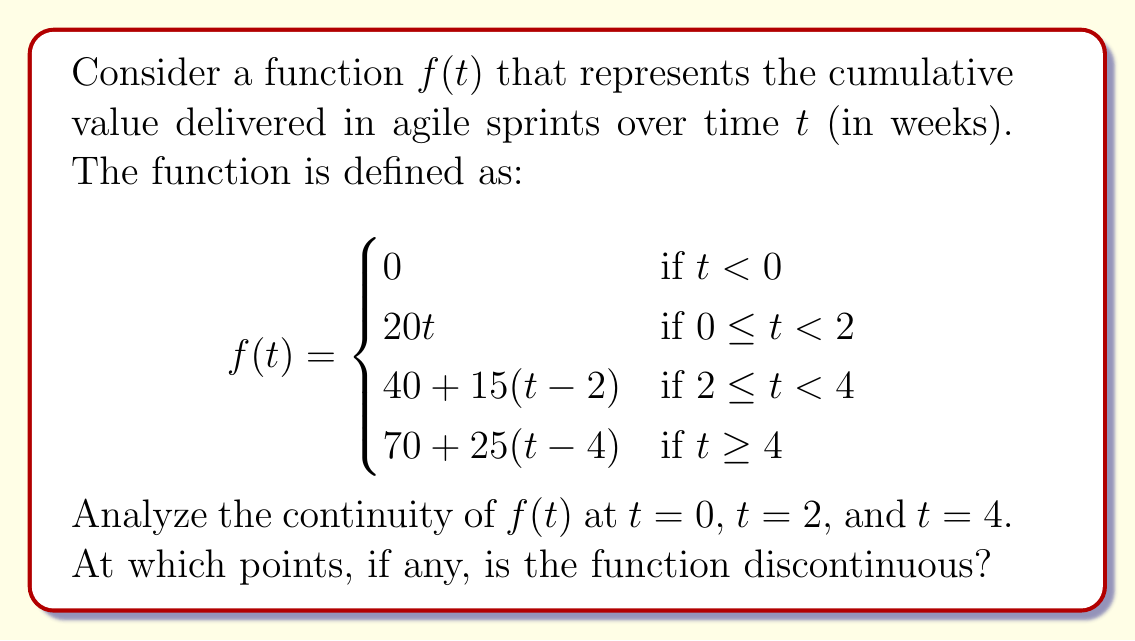Can you solve this math problem? To analyze the continuity of $f(t)$ at the given points, we need to check if the function satisfies the three conditions for continuity at each point:

1. The function must be defined at the point.
2. The limit of the function as we approach the point from both sides must exist.
3. The limit must equal the function value at that point.

Let's examine each point:

1. At $t = 0$:
   - $f(0)$ is defined (equals 0).
   - Left limit: $\lim_{t \to 0^-} f(t) = 0$
   - Right limit: $\lim_{t \to 0^+} f(t) = 0$
   - Both limits exist and are equal to $f(0)$, so $f(t)$ is continuous at $t = 0$.

2. At $t = 2$:
   - $f(2)$ is defined (equals 40).
   - Left limit: $\lim_{t \to 2^-} f(t) = 20 \cdot 2 = 40$
   - Right limit: $\lim_{t \to 2^+} f(t) = 40 + 15(2-2) = 40$
   - Both limits exist and are equal to $f(2)$, so $f(t)$ is continuous at $t = 2$.

3. At $t = 4$:
   - $f(4)$ is defined (equals 70).
   - Left limit: $\lim_{t \to 4^-} f(t) = 40 + 15(4-2) = 70$
   - Right limit: $\lim_{t \to 4^+} f(t) = 70 + 25(4-4) = 70$
   - Both limits exist and are equal to $f(4)$, so $f(t)$ is continuous at $t = 4$.

Since the function is continuous at all three points of interest, we can conclude that there are no discontinuities at these points.
Answer: The function $f(t)$ is continuous at $t = 0$, $t = 2$, and $t = 4$. There are no discontinuities at these points. 